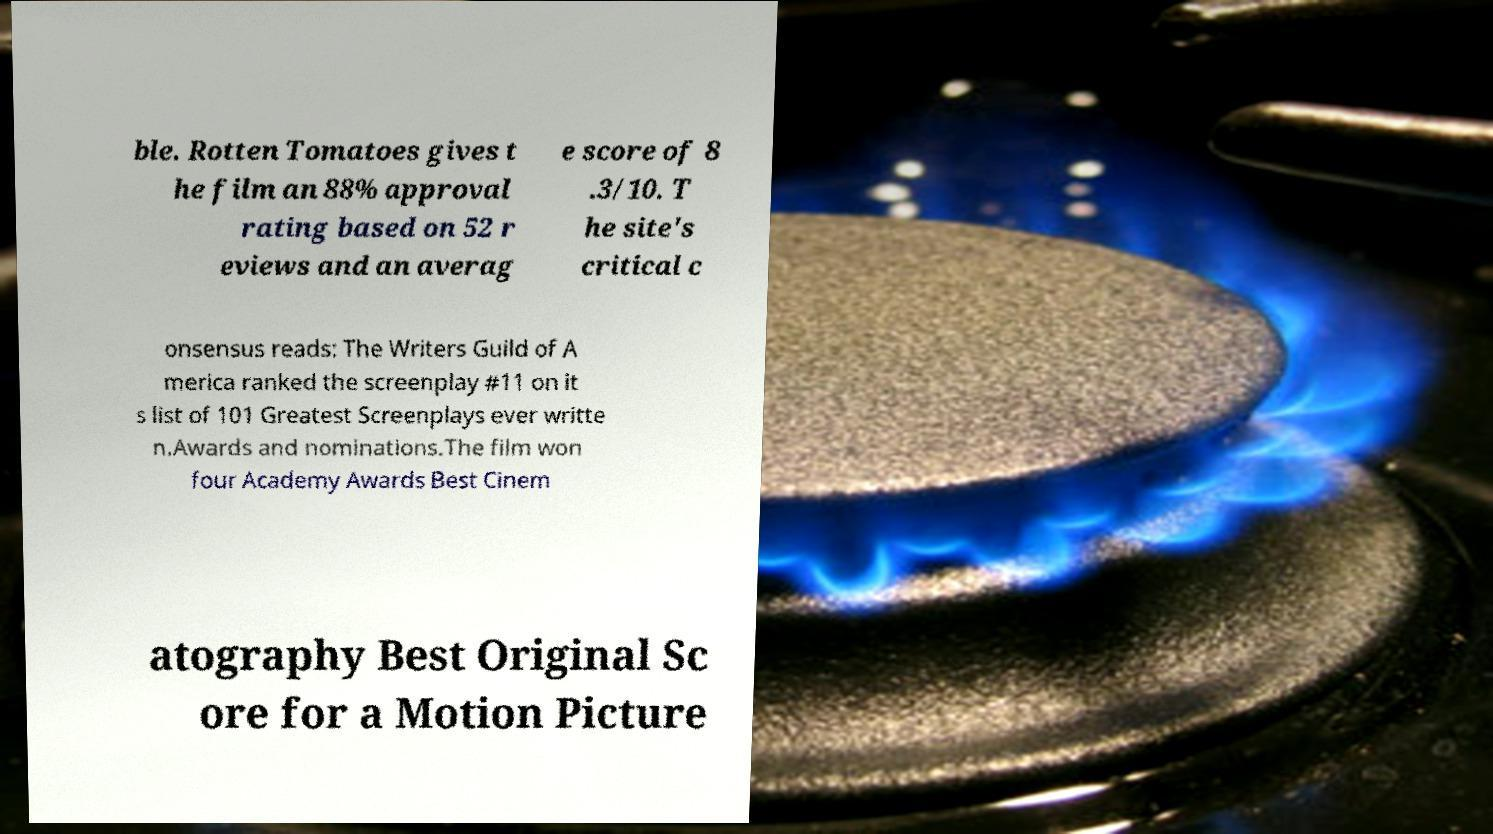There's text embedded in this image that I need extracted. Can you transcribe it verbatim? ble. Rotten Tomatoes gives t he film an 88% approval rating based on 52 r eviews and an averag e score of 8 .3/10. T he site's critical c onsensus reads: The Writers Guild of A merica ranked the screenplay #11 on it s list of 101 Greatest Screenplays ever writte n.Awards and nominations.The film won four Academy Awards Best Cinem atography Best Original Sc ore for a Motion Picture 